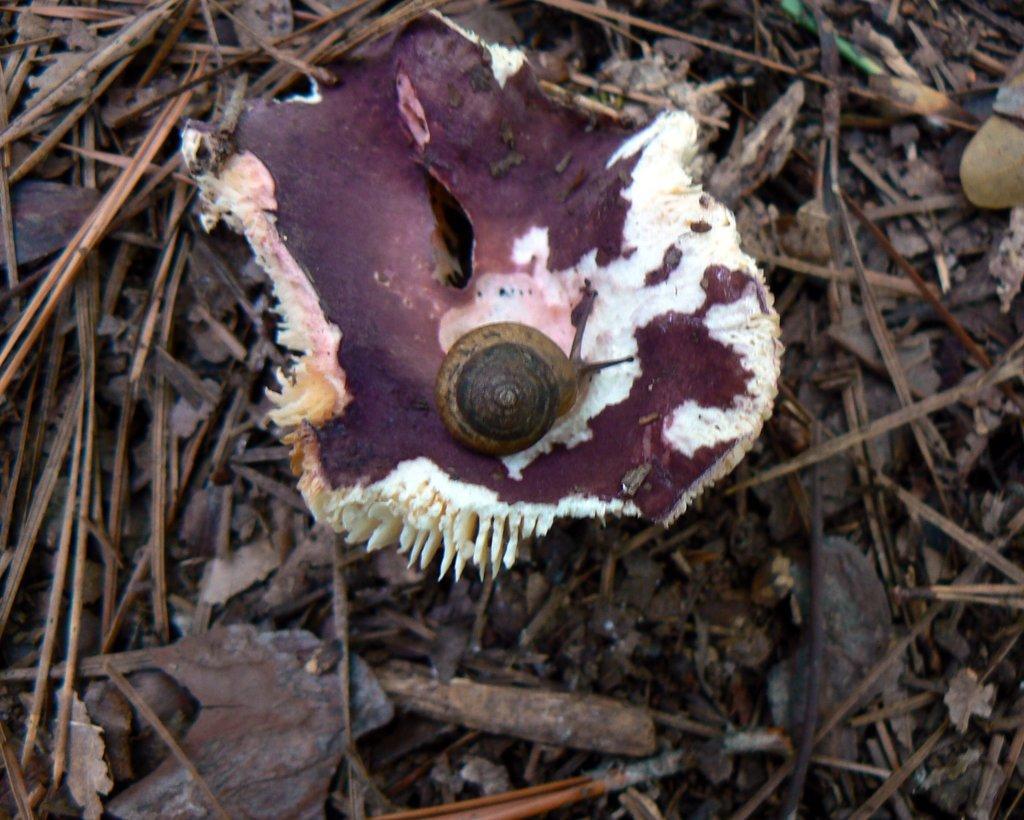Please provide a concise description of this image. In this image there is a snail on something thing which is on the wooden pieces. 